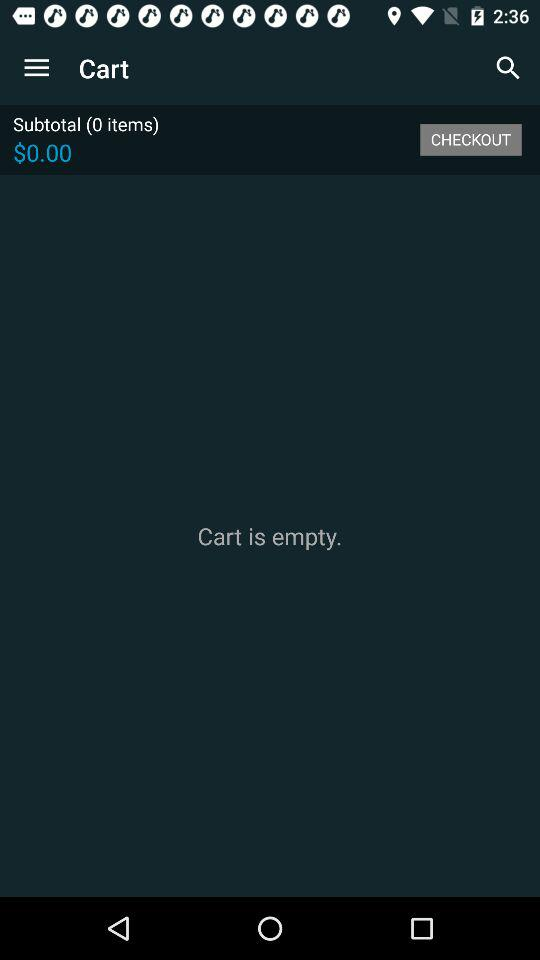What is the currency for the price? The currency is "$". 